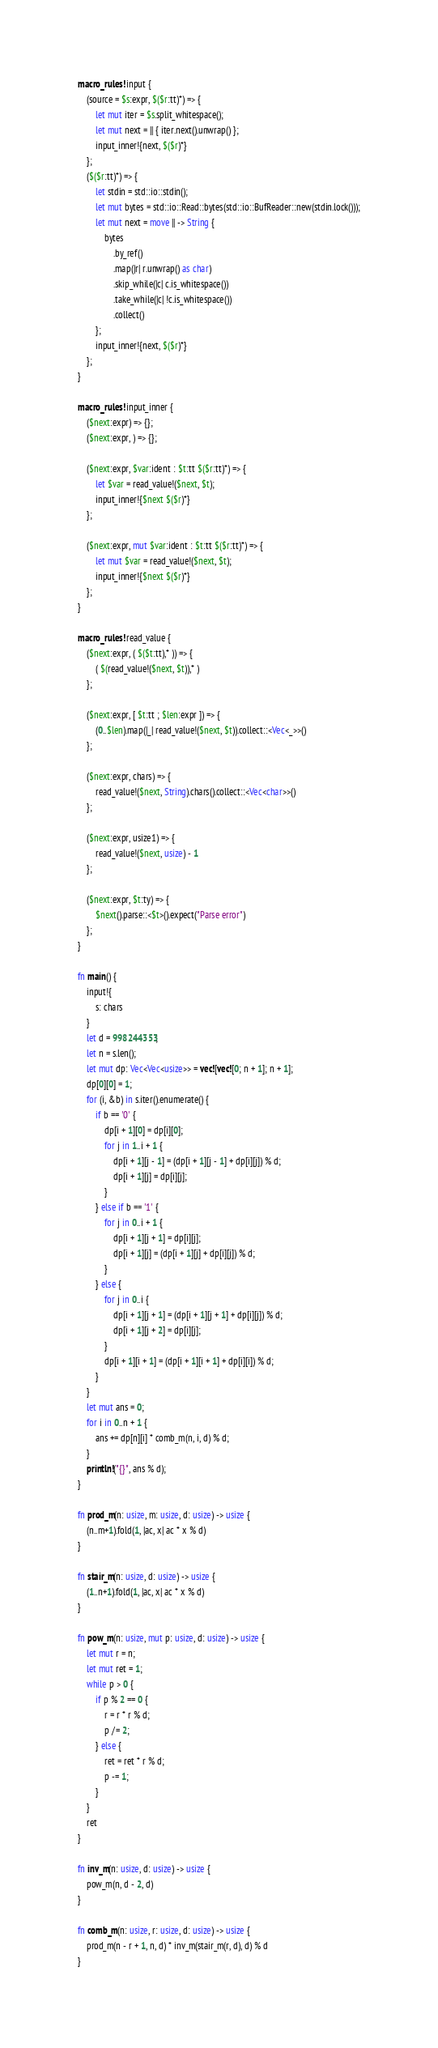<code> <loc_0><loc_0><loc_500><loc_500><_Rust_>macro_rules! input {
    (source = $s:expr, $($r:tt)*) => {
        let mut iter = $s.split_whitespace();
        let mut next = || { iter.next().unwrap() };
        input_inner!{next, $($r)*}
    };
    ($($r:tt)*) => {
        let stdin = std::io::stdin();
        let mut bytes = std::io::Read::bytes(std::io::BufReader::new(stdin.lock()));
        let mut next = move || -> String {
            bytes
                .by_ref()
                .map(|r| r.unwrap() as char)
                .skip_while(|c| c.is_whitespace())
                .take_while(|c| !c.is_whitespace())
                .collect()
        };
        input_inner!{next, $($r)*}
    };
}

macro_rules! input_inner {
    ($next:expr) => {};
    ($next:expr, ) => {};

    ($next:expr, $var:ident : $t:tt $($r:tt)*) => {
        let $var = read_value!($next, $t);
        input_inner!{$next $($r)*}
    };

    ($next:expr, mut $var:ident : $t:tt $($r:tt)*) => {
        let mut $var = read_value!($next, $t);
        input_inner!{$next $($r)*}
    };
}

macro_rules! read_value {
    ($next:expr, ( $($t:tt),* )) => {
        ( $(read_value!($next, $t)),* )
    };

    ($next:expr, [ $t:tt ; $len:expr ]) => {
        (0..$len).map(|_| read_value!($next, $t)).collect::<Vec<_>>()
    };

    ($next:expr, chars) => {
        read_value!($next, String).chars().collect::<Vec<char>>()
    };

    ($next:expr, usize1) => {
        read_value!($next, usize) - 1
    };

    ($next:expr, $t:ty) => {
        $next().parse::<$t>().expect("Parse error")
    };
}

fn main() {
    input!{
        s: chars
    }
    let d = 998244353;
    let n = s.len();
    let mut dp: Vec<Vec<usize>> = vec![vec![0; n + 1]; n + 1];
    dp[0][0] = 1;
    for (i, &b) in s.iter().enumerate() {
        if b == '0' {
            dp[i + 1][0] = dp[i][0];
            for j in 1..i + 1 {
                dp[i + 1][j - 1] = (dp[i + 1][j - 1] + dp[i][j]) % d;
                dp[i + 1][j] = dp[i][j];
            }
        } else if b == '1' {
            for j in 0..i + 1 {
                dp[i + 1][j + 1] = dp[i][j];
                dp[i + 1][j] = (dp[i + 1][j] + dp[i][j]) % d;
            }
        } else {
            for j in 0..i {
                dp[i + 1][j + 1] = (dp[i + 1][j + 1] + dp[i][j]) % d;
                dp[i + 1][j + 2] = dp[i][j];
            }
            dp[i + 1][i + 1] = (dp[i + 1][i + 1] + dp[i][i]) % d;
        }
    }
    let mut ans = 0;
    for i in 0..n + 1 {
        ans += dp[n][i] * comb_m(n, i, d) % d;
    }
    println!("{}", ans % d);
}

fn prod_m(n: usize, m: usize, d: usize) -> usize {
    (n..m+1).fold(1, |ac, x| ac * x % d)
}

fn stair_m(n: usize, d: usize) -> usize {
    (1..n+1).fold(1, |ac, x| ac * x % d)
}

fn pow_m(n: usize, mut p: usize, d: usize) -> usize {
    let mut r = n;
    let mut ret = 1;
    while p > 0 {
        if p % 2 == 0 {
            r = r * r % d;
            p /= 2;
        } else {
            ret = ret * r % d;
            p -= 1;
        }
    }
    ret
}

fn inv_m(n: usize, d: usize) -> usize {
    pow_m(n, d - 2, d)
}

fn comb_m(n: usize, r: usize, d: usize) -> usize {
    prod_m(n - r + 1, n, d) * inv_m(stair_m(r, d), d) % d
}
</code> 